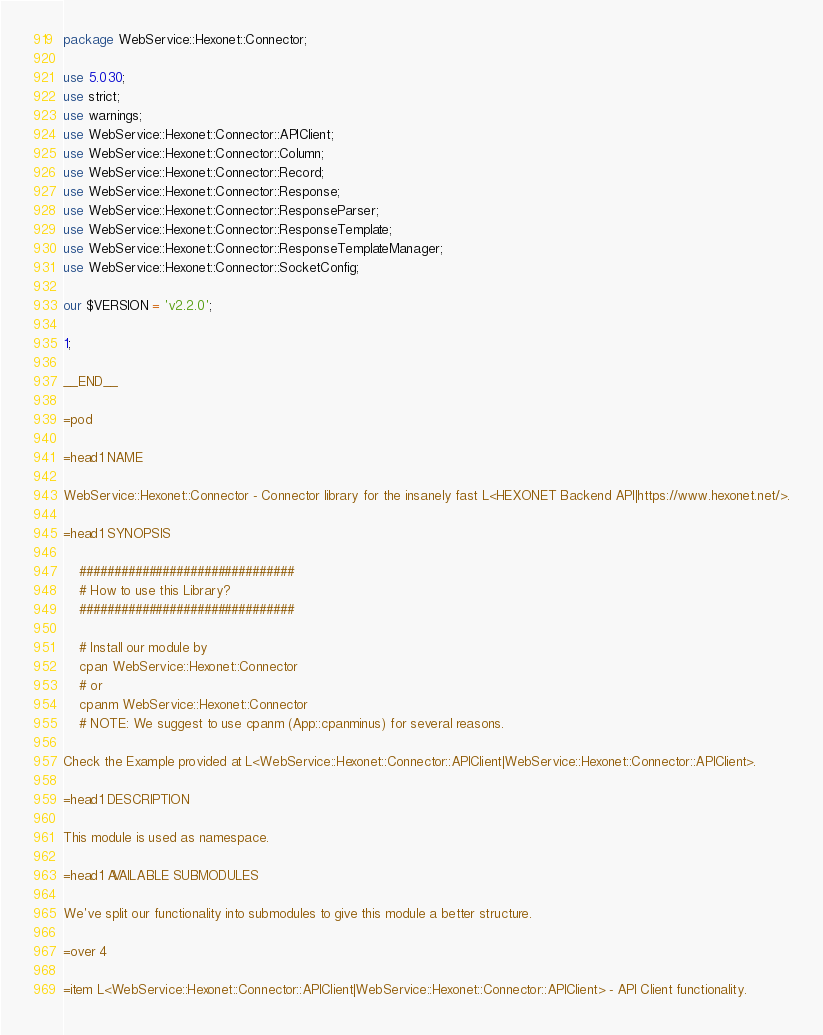Convert code to text. <code><loc_0><loc_0><loc_500><loc_500><_Perl_>package WebService::Hexonet::Connector;

use 5.030;
use strict;
use warnings;
use WebService::Hexonet::Connector::APIClient;
use WebService::Hexonet::Connector::Column;
use WebService::Hexonet::Connector::Record;
use WebService::Hexonet::Connector::Response;
use WebService::Hexonet::Connector::ResponseParser;
use WebService::Hexonet::Connector::ResponseTemplate;
use WebService::Hexonet::Connector::ResponseTemplateManager;
use WebService::Hexonet::Connector::SocketConfig;

our $VERSION = 'v2.2.0';

1;

__END__

=pod

=head1 NAME

WebService::Hexonet::Connector - Connector library for the insanely fast L<HEXONET Backend API|https://www.hexonet.net/>.

=head1 SYNOPSIS

	###############################
	# How to use this Library?
	###############################

	# Install our module by
	cpan WebService::Hexonet::Connector
	# or
	cpanm WebService::Hexonet::Connector
	# NOTE: We suggest to use cpanm (App::cpanminus) for several reasons.

Check the Example provided at L<WebService::Hexonet::Connector::APIClient|WebService::Hexonet::Connector::APIClient>.

=head1 DESCRIPTION

This module is used as namespace.

=head1 AVAILABLE SUBMODULES

We've split our functionality into submodules to give this module a better structure.

=over 4

=item L<WebService::Hexonet::Connector::APIClient|WebService::Hexonet::Connector::APIClient> - API Client functionality.
</code> 